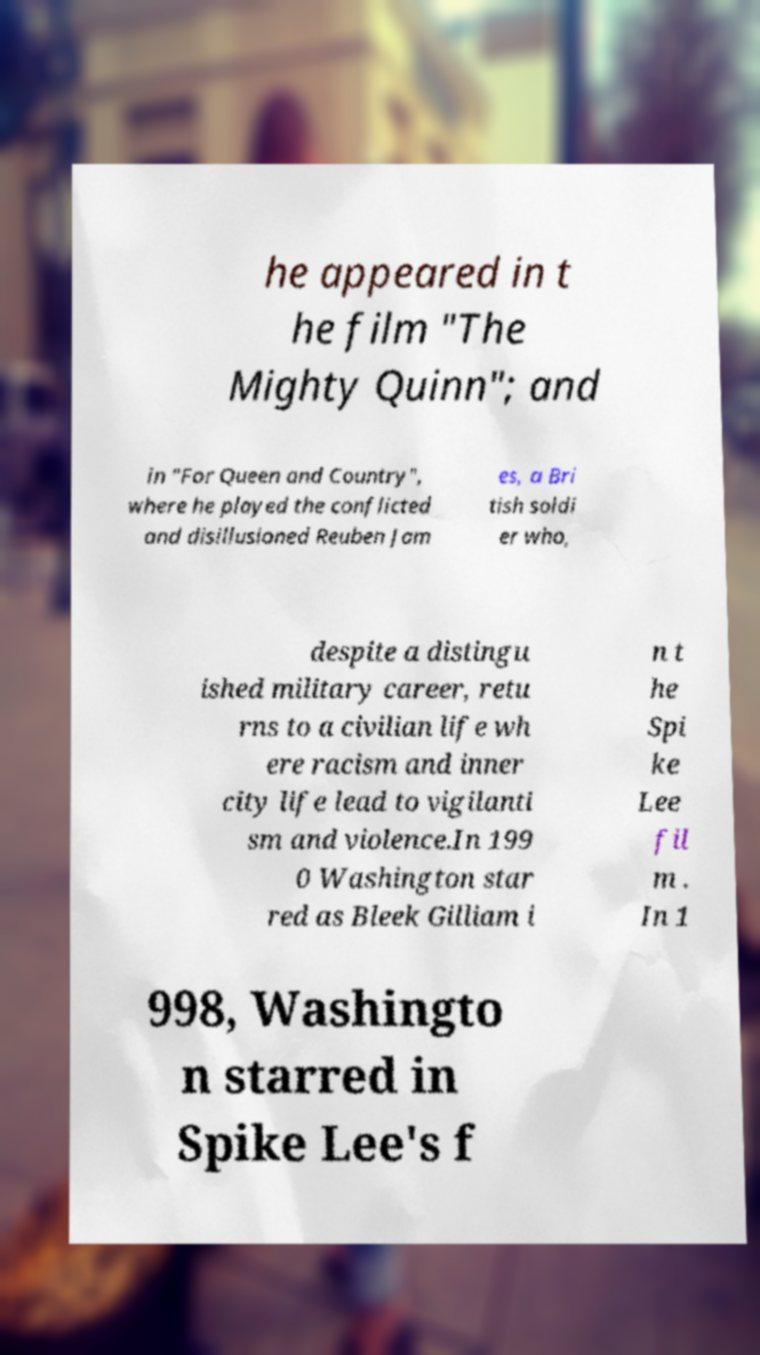Could you extract and type out the text from this image? he appeared in t he film "The Mighty Quinn"; and in "For Queen and Country", where he played the conflicted and disillusioned Reuben Jam es, a Bri tish soldi er who, despite a distingu ished military career, retu rns to a civilian life wh ere racism and inner city life lead to vigilanti sm and violence.In 199 0 Washington star red as Bleek Gilliam i n t he Spi ke Lee fil m . In 1 998, Washingto n starred in Spike Lee's f 